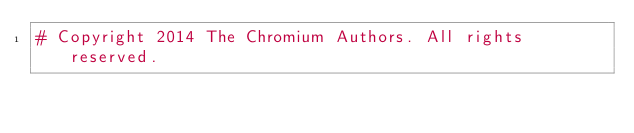<code> <loc_0><loc_0><loc_500><loc_500><_Python_># Copyright 2014 The Chromium Authors. All rights reserved.</code> 